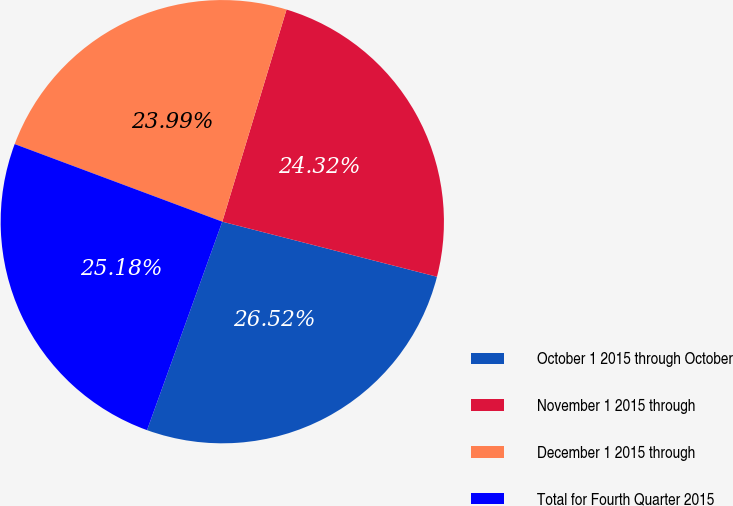Convert chart to OTSL. <chart><loc_0><loc_0><loc_500><loc_500><pie_chart><fcel>October 1 2015 through October<fcel>November 1 2015 through<fcel>December 1 2015 through<fcel>Total for Fourth Quarter 2015<nl><fcel>26.52%<fcel>24.32%<fcel>23.99%<fcel>25.18%<nl></chart> 